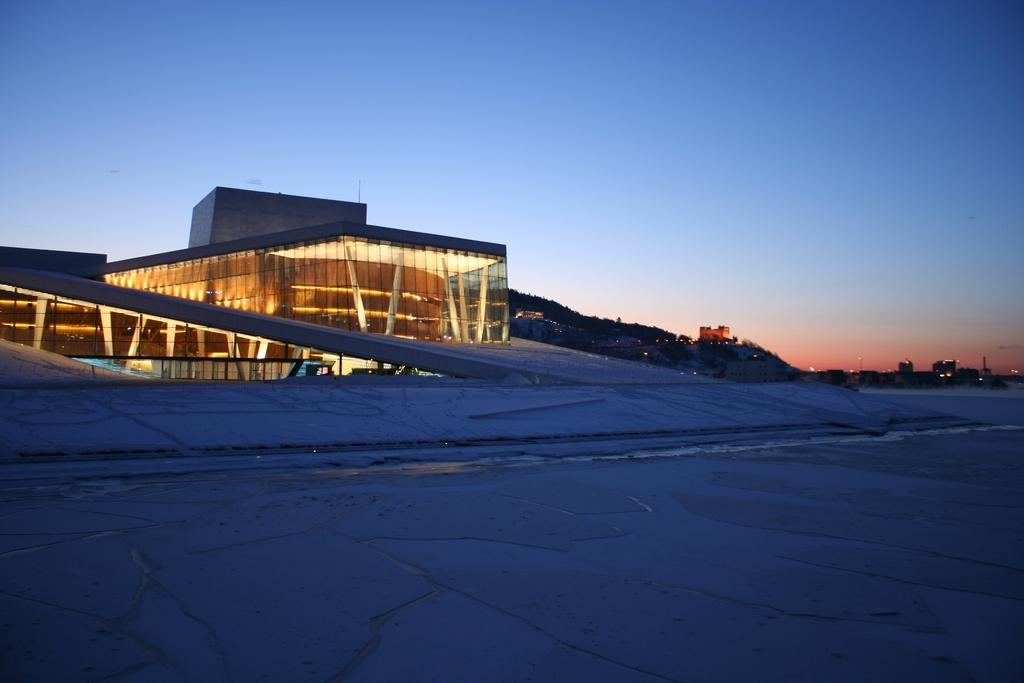What is the main feature of the image? There is a road in the image. What else can be seen in the image besides the road? There is a building, lights, trees, and the sky visible in the background of the image. How many snails can be seen crawling on the library in the image? There is no library or snails present in the image. 